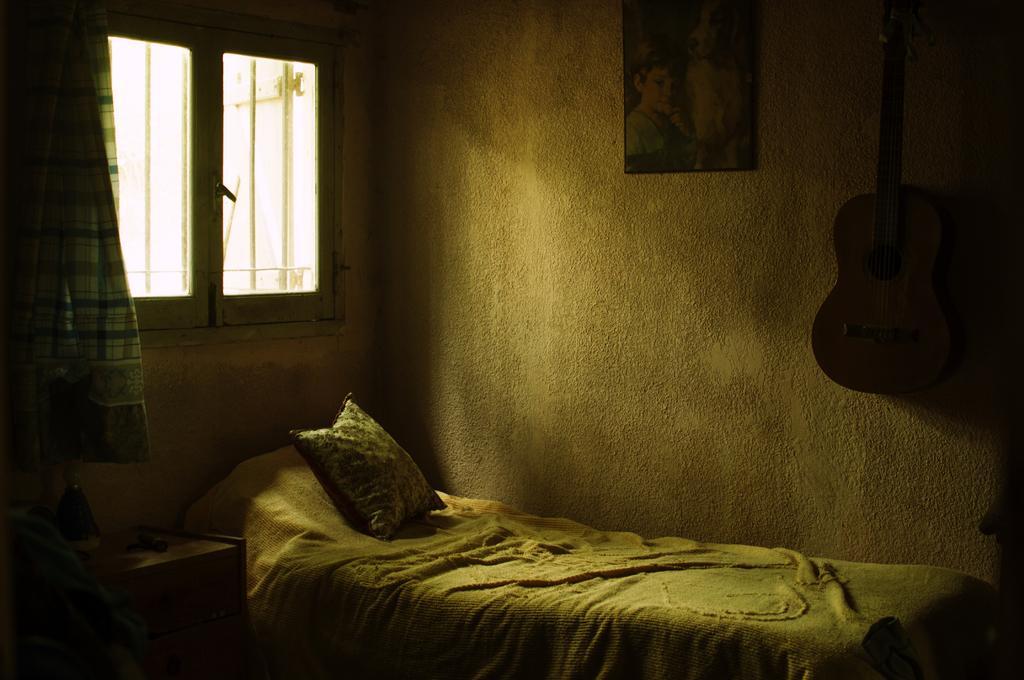Describe this image in one or two sentences. This picture shows a bed pillow and a photo frame on the wall and a guitar hanging to the wall 